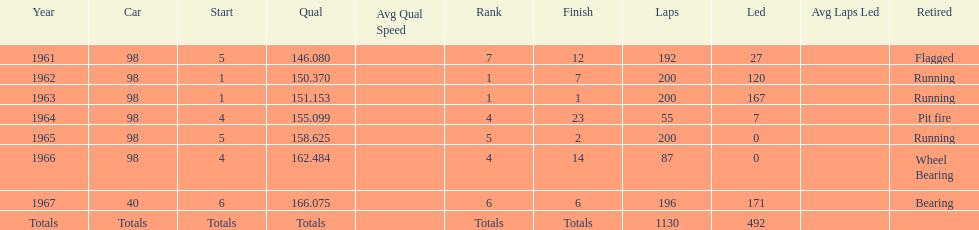What car ranked #1 from 1962-1963? 98. 